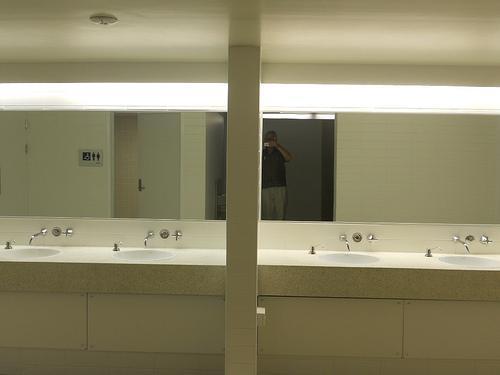How many people are in the photo?
Give a very brief answer. 1. 